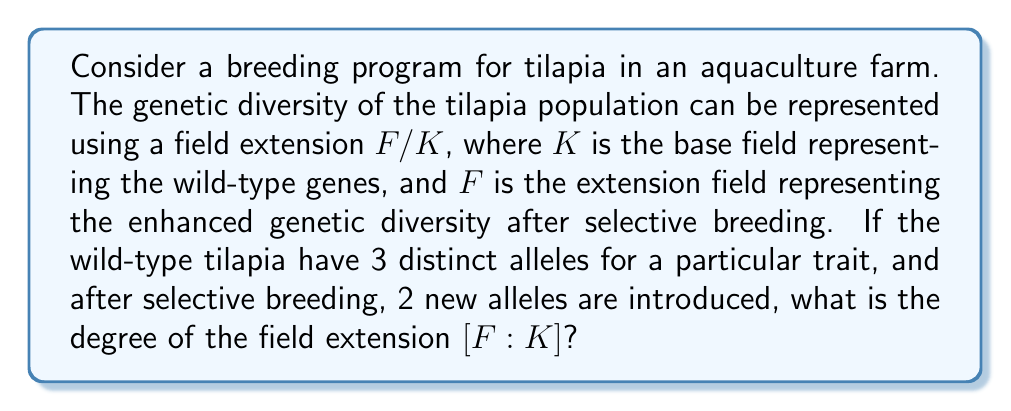Show me your answer to this math problem. To solve this problem, we need to understand how field extensions can represent genetic diversity:

1) The base field $K$ represents the genetic pool of wild-type tilapia. Each element in this field corresponds to a distinct allele in the wild population.

2) The extension field $F$ represents the expanded genetic pool after selective breeding, which includes both the original alleles and the newly introduced ones.

3) The degree of the field extension $[F:K]$ represents the factor by which genetic diversity has increased.

Given:
- Wild-type tilapia have 3 distinct alleles for a particular trait.
- After selective breeding, 2 new alleles are introduced.

To find $[F:K]$:

1) The number of elements in the base field $K$ is 3 (representing the 3 wild-type alleles).

2) The total number of elements in the extension field $F$ is 5 (3 original + 2 new alleles).

3) The degree of the field extension is given by:

   $$[F:K] = \frac{|F|}{|K|} = \frac{5}{3}$$

This fractional result indicates that the field extension is not a simple algebraic extension, but rather a transcendental extension. In the context of genetics, this suggests that the new alleles are not simple combinations of existing alleles but represent genuinely new genetic information.
Answer: $[F:K] = \frac{5}{3}$ 